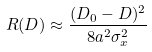<formula> <loc_0><loc_0><loc_500><loc_500>R ( D ) \approx \frac { ( D _ { 0 } - D ) ^ { 2 } } { 8 a ^ { 2 } \sigma _ { x } ^ { 2 } }</formula> 